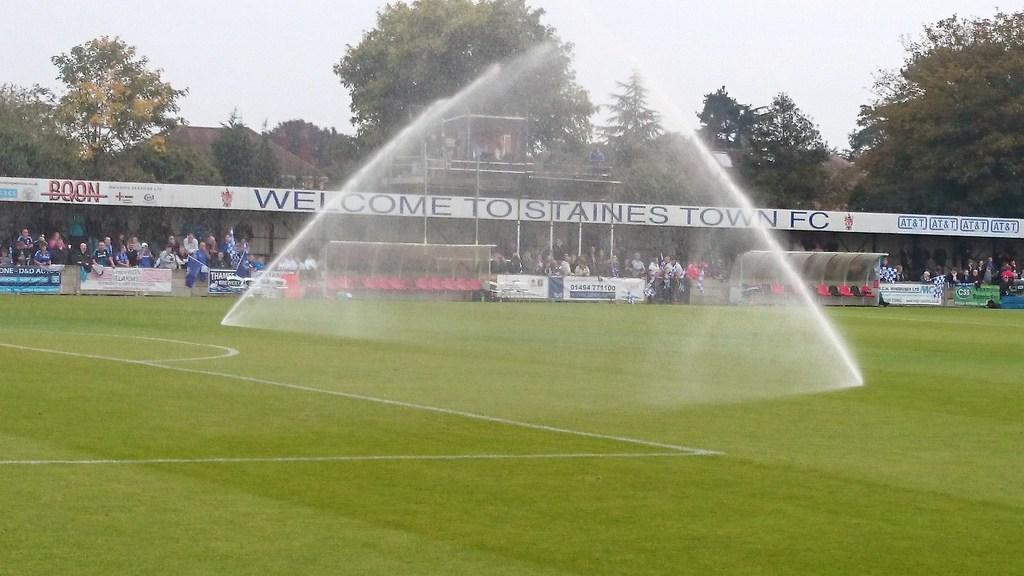<image>
Summarize the visual content of the image. A soccer field and there is a banner that has "Welcome" on it in the back. 